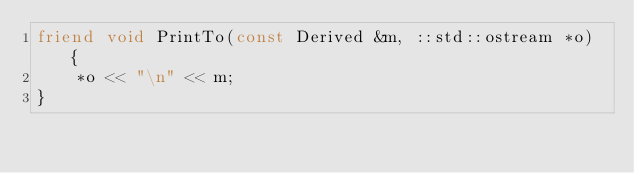<code> <loc_0><loc_0><loc_500><loc_500><_C++_>friend void PrintTo(const Derived &m, ::std::ostream *o) {
    *o << "\n" << m;
}</code> 